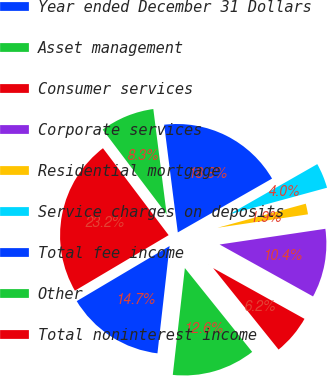Convert chart. <chart><loc_0><loc_0><loc_500><loc_500><pie_chart><fcel>Year ended December 31 Dollars<fcel>Asset management<fcel>Consumer services<fcel>Corporate services<fcel>Residential mortgage<fcel>Service charges on deposits<fcel>Total fee income<fcel>Other<fcel>Total noninterest income<nl><fcel>14.69%<fcel>12.56%<fcel>6.16%<fcel>10.42%<fcel>1.89%<fcel>4.02%<fcel>18.75%<fcel>8.29%<fcel>23.22%<nl></chart> 